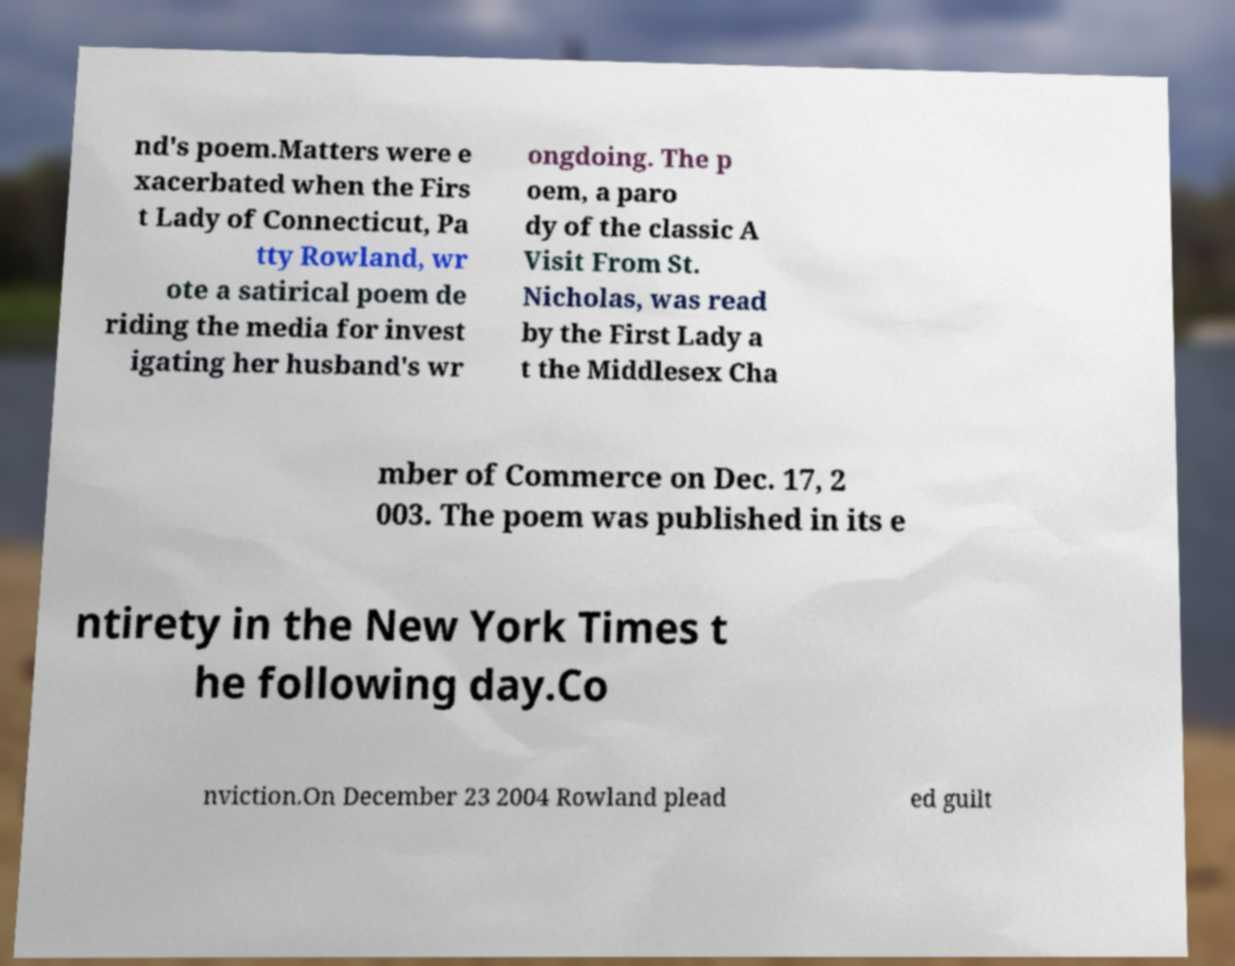What messages or text are displayed in this image? I need them in a readable, typed format. nd's poem.Matters were e xacerbated when the Firs t Lady of Connecticut, Pa tty Rowland, wr ote a satirical poem de riding the media for invest igating her husband's wr ongdoing. The p oem, a paro dy of the classic A Visit From St. Nicholas, was read by the First Lady a t the Middlesex Cha mber of Commerce on Dec. 17, 2 003. The poem was published in its e ntirety in the New York Times t he following day.Co nviction.On December 23 2004 Rowland plead ed guilt 